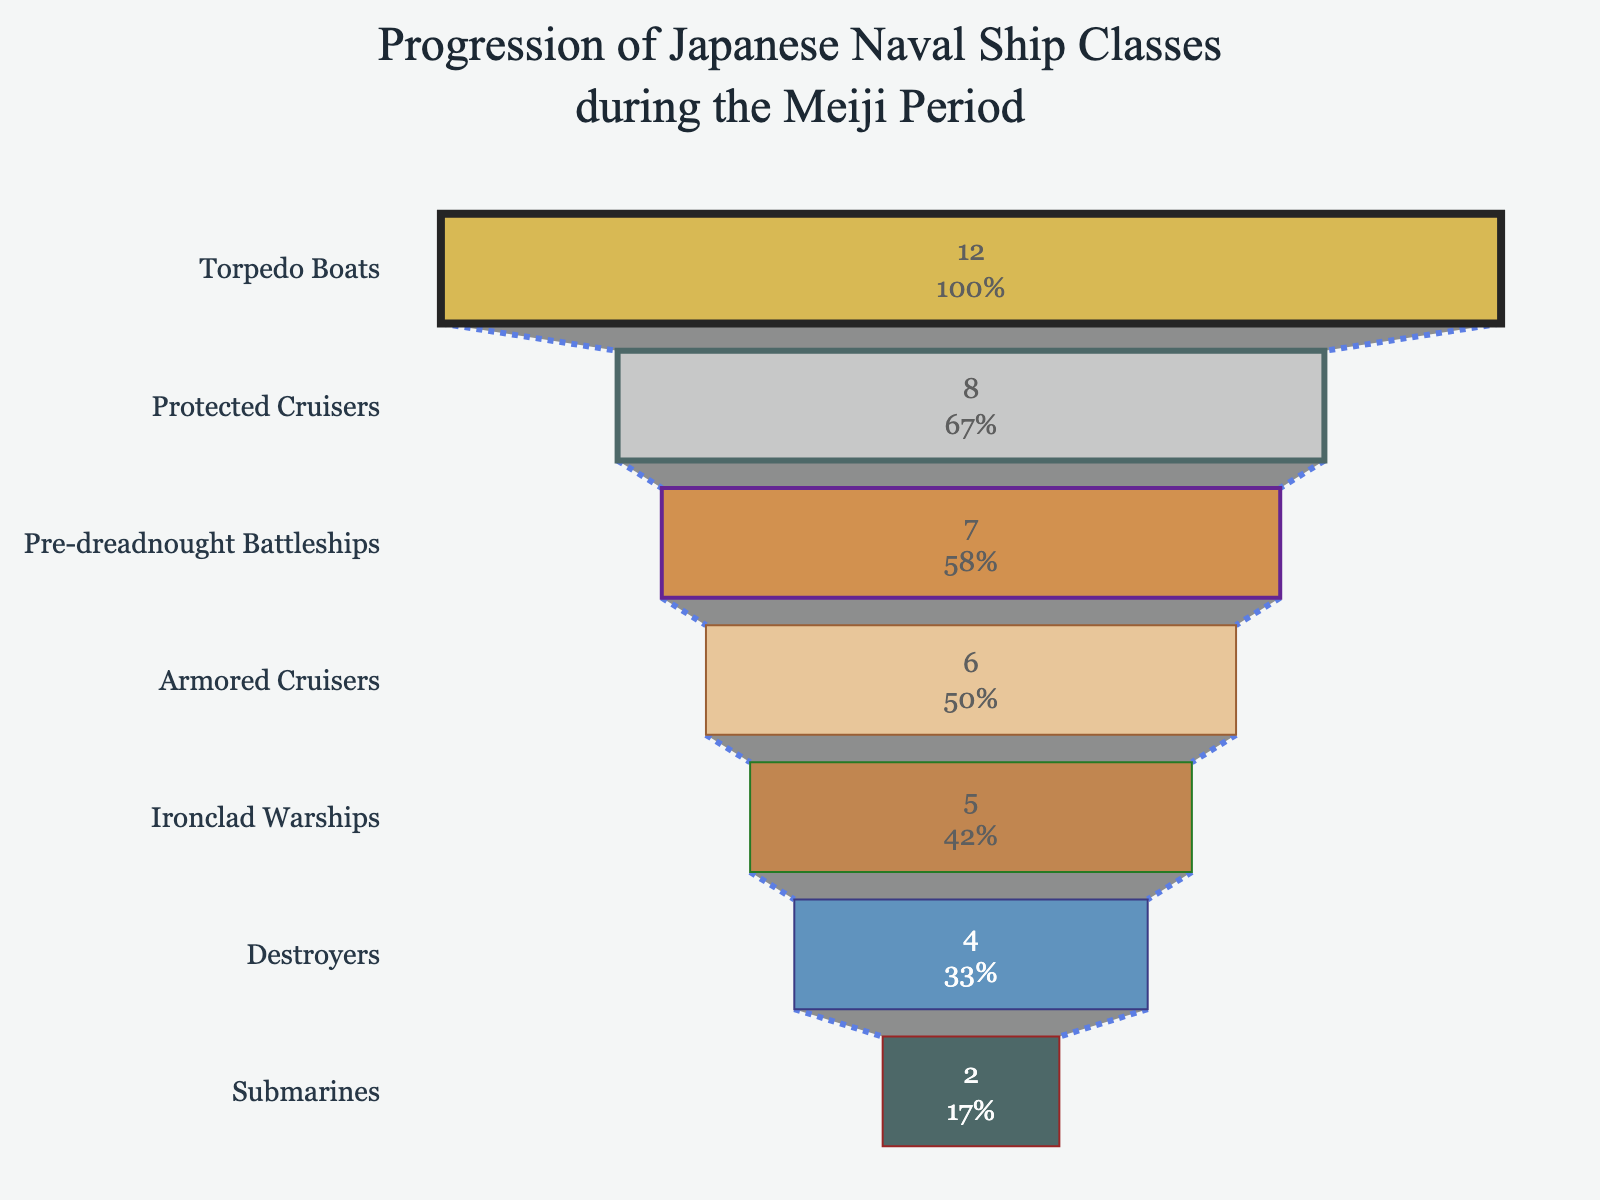What's the title of the funnel chart? The title is located at the top of the funnel chart and is descriptive to provide context. It reads: "Progression of Japanese Naval Ship Classes during the Meiji Period".
Answer: Progression of Japanese Naval Ship Classes during the Meiji Period Which class of ships had the highest number? Identify the widest part of the funnel chart, which represents the class with the largest number. This is "Torpedo Boats" with 12 ship classes.
Answer: Torpedo Boats (12) How many more Protected Cruisers were there compared to Submarines? Look at the values for Protected Cruisers (8) and Submarines (2). Subtract the number of Submarines from Protected Cruisers: 8 - 2 = 6.
Answer: 6 List the ship classes that have more than 5 classes. Scan through the funnel sections to find those with values greater than 5. These are Torpedo Boats (12), Protected Cruisers (8), Pre-dreadnought Battleships (7), and Armored Cruisers (6).
Answer: Torpedo Boats, Protected Cruisers, Pre-dreadnought Battleships, Armored Cruisers What's the combined total of ship classes for Ironclad Warships and Destroyers? Sum the values for Ironclad Warships (5) and Destroyers (4): 5 + 4 = 9.
Answer: 9 Which ship class is second in quantity after Torpedo Boats? After identifying that Torpedo Boats have the highest count, find the next largest value which is Protected Cruisers with 8 ship classes.
Answer: Protected Cruisers What percentage of the total initial ship classes do Pre-dreadnought Battleships account for? Find the total number of ship classes by summing all values: 5 + 8 + 6 + 7 + 4 + 12 + 2 = 44. Then calculate the percentage for Pre-dreadnought Battleships with 7 classes: (7 / 44) * 100 ≈ 15.91%.
Answer: Approximately 15.91% What is the difference in the number of ship classes between the smallest and the largest categories? Find the difference between the category with the most ship classes (Torpedo Boats, 12) and the category with the least (Submarines, 2): 12 - 2 = 10.
Answer: 10 How many ship classes are accounted for by Armored Cruisers and Destroyers together? Add the values for Armored Cruisers (6) and Destroyers (4): 6 + 4 = 10.
Answer: 10 